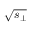<formula> <loc_0><loc_0><loc_500><loc_500>\sqrt { s _ { \perp } }</formula> 